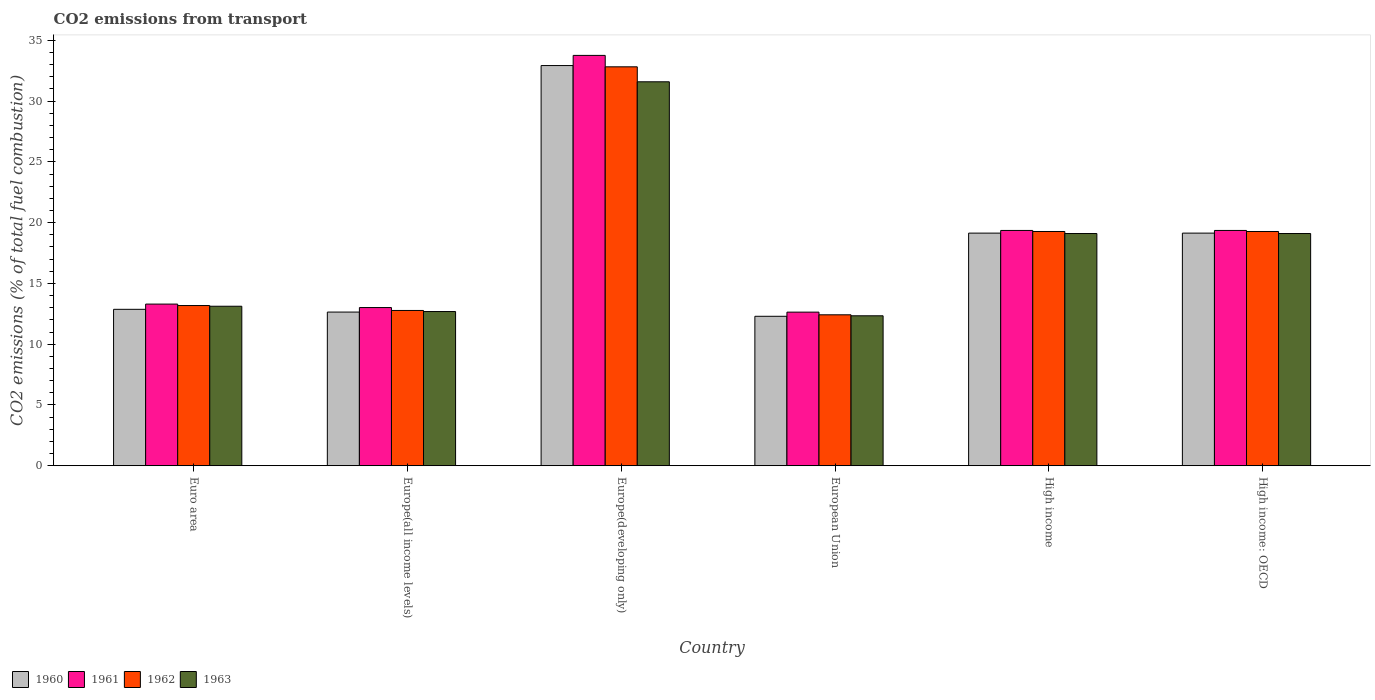How many bars are there on the 3rd tick from the left?
Offer a terse response. 4. What is the label of the 6th group of bars from the left?
Keep it short and to the point. High income: OECD. What is the total CO2 emitted in 1962 in Euro area?
Your response must be concise. 13.18. Across all countries, what is the maximum total CO2 emitted in 1961?
Provide a short and direct response. 33.76. Across all countries, what is the minimum total CO2 emitted in 1963?
Your response must be concise. 12.34. In which country was the total CO2 emitted in 1961 maximum?
Keep it short and to the point. Europe(developing only). In which country was the total CO2 emitted in 1962 minimum?
Offer a terse response. European Union. What is the total total CO2 emitted in 1962 in the graph?
Ensure brevity in your answer.  109.75. What is the difference between the total CO2 emitted in 1961 in Euro area and that in High income: OECD?
Your answer should be compact. -6.06. What is the difference between the total CO2 emitted in 1962 in Euro area and the total CO2 emitted in 1960 in Europe(developing only)?
Offer a very short reply. -19.75. What is the average total CO2 emitted in 1963 per country?
Your response must be concise. 17.99. What is the difference between the total CO2 emitted of/in 1963 and total CO2 emitted of/in 1962 in Euro area?
Offer a terse response. -0.06. In how many countries, is the total CO2 emitted in 1963 greater than 34?
Your answer should be compact. 0. What is the ratio of the total CO2 emitted in 1960 in Euro area to that in High income: OECD?
Your answer should be compact. 0.67. Is the total CO2 emitted in 1962 in Europe(all income levels) less than that in High income: OECD?
Keep it short and to the point. Yes. Is the difference between the total CO2 emitted in 1963 in Europe(developing only) and High income: OECD greater than the difference between the total CO2 emitted in 1962 in Europe(developing only) and High income: OECD?
Your answer should be very brief. No. What is the difference between the highest and the second highest total CO2 emitted in 1960?
Keep it short and to the point. 13.79. What is the difference between the highest and the lowest total CO2 emitted in 1960?
Your answer should be very brief. 20.63. Is the sum of the total CO2 emitted in 1962 in Euro area and High income: OECD greater than the maximum total CO2 emitted in 1961 across all countries?
Your answer should be compact. No. Is it the case that in every country, the sum of the total CO2 emitted in 1961 and total CO2 emitted in 1963 is greater than the sum of total CO2 emitted in 1960 and total CO2 emitted in 1962?
Offer a terse response. No. What does the 4th bar from the left in European Union represents?
Make the answer very short. 1963. What does the 3rd bar from the right in European Union represents?
Ensure brevity in your answer.  1961. Are all the bars in the graph horizontal?
Provide a succinct answer. No. Does the graph contain any zero values?
Offer a terse response. No. How many legend labels are there?
Make the answer very short. 4. What is the title of the graph?
Keep it short and to the point. CO2 emissions from transport. What is the label or title of the X-axis?
Your response must be concise. Country. What is the label or title of the Y-axis?
Offer a terse response. CO2 emissions (% of total fuel combustion). What is the CO2 emissions (% of total fuel combustion) of 1960 in Euro area?
Your response must be concise. 12.87. What is the CO2 emissions (% of total fuel combustion) in 1961 in Euro area?
Offer a terse response. 13.3. What is the CO2 emissions (% of total fuel combustion) of 1962 in Euro area?
Offer a very short reply. 13.18. What is the CO2 emissions (% of total fuel combustion) in 1963 in Euro area?
Offer a very short reply. 13.12. What is the CO2 emissions (% of total fuel combustion) in 1960 in Europe(all income levels)?
Make the answer very short. 12.64. What is the CO2 emissions (% of total fuel combustion) in 1961 in Europe(all income levels)?
Keep it short and to the point. 13.01. What is the CO2 emissions (% of total fuel combustion) of 1962 in Europe(all income levels)?
Keep it short and to the point. 12.78. What is the CO2 emissions (% of total fuel combustion) of 1963 in Europe(all income levels)?
Provide a short and direct response. 12.69. What is the CO2 emissions (% of total fuel combustion) in 1960 in Europe(developing only)?
Keep it short and to the point. 32.93. What is the CO2 emissions (% of total fuel combustion) of 1961 in Europe(developing only)?
Offer a very short reply. 33.76. What is the CO2 emissions (% of total fuel combustion) of 1962 in Europe(developing only)?
Give a very brief answer. 32.82. What is the CO2 emissions (% of total fuel combustion) in 1963 in Europe(developing only)?
Provide a succinct answer. 31.59. What is the CO2 emissions (% of total fuel combustion) in 1960 in European Union?
Offer a very short reply. 12.3. What is the CO2 emissions (% of total fuel combustion) in 1961 in European Union?
Your response must be concise. 12.64. What is the CO2 emissions (% of total fuel combustion) of 1962 in European Union?
Ensure brevity in your answer.  12.42. What is the CO2 emissions (% of total fuel combustion) in 1963 in European Union?
Offer a terse response. 12.34. What is the CO2 emissions (% of total fuel combustion) in 1960 in High income?
Your answer should be compact. 19.14. What is the CO2 emissions (% of total fuel combustion) in 1961 in High income?
Provide a short and direct response. 19.36. What is the CO2 emissions (% of total fuel combustion) in 1962 in High income?
Your answer should be very brief. 19.27. What is the CO2 emissions (% of total fuel combustion) in 1963 in High income?
Make the answer very short. 19.11. What is the CO2 emissions (% of total fuel combustion) of 1960 in High income: OECD?
Make the answer very short. 19.14. What is the CO2 emissions (% of total fuel combustion) in 1961 in High income: OECD?
Offer a very short reply. 19.36. What is the CO2 emissions (% of total fuel combustion) in 1962 in High income: OECD?
Offer a terse response. 19.27. What is the CO2 emissions (% of total fuel combustion) of 1963 in High income: OECD?
Offer a very short reply. 19.11. Across all countries, what is the maximum CO2 emissions (% of total fuel combustion) of 1960?
Make the answer very short. 32.93. Across all countries, what is the maximum CO2 emissions (% of total fuel combustion) of 1961?
Provide a succinct answer. 33.76. Across all countries, what is the maximum CO2 emissions (% of total fuel combustion) in 1962?
Give a very brief answer. 32.82. Across all countries, what is the maximum CO2 emissions (% of total fuel combustion) of 1963?
Offer a terse response. 31.59. Across all countries, what is the minimum CO2 emissions (% of total fuel combustion) in 1960?
Provide a short and direct response. 12.3. Across all countries, what is the minimum CO2 emissions (% of total fuel combustion) of 1961?
Keep it short and to the point. 12.64. Across all countries, what is the minimum CO2 emissions (% of total fuel combustion) of 1962?
Your answer should be compact. 12.42. Across all countries, what is the minimum CO2 emissions (% of total fuel combustion) in 1963?
Your answer should be compact. 12.34. What is the total CO2 emissions (% of total fuel combustion) of 1960 in the graph?
Give a very brief answer. 109.02. What is the total CO2 emissions (% of total fuel combustion) of 1961 in the graph?
Offer a very short reply. 111.44. What is the total CO2 emissions (% of total fuel combustion) of 1962 in the graph?
Provide a short and direct response. 109.75. What is the total CO2 emissions (% of total fuel combustion) in 1963 in the graph?
Make the answer very short. 107.96. What is the difference between the CO2 emissions (% of total fuel combustion) of 1960 in Euro area and that in Europe(all income levels)?
Make the answer very short. 0.23. What is the difference between the CO2 emissions (% of total fuel combustion) of 1961 in Euro area and that in Europe(all income levels)?
Provide a succinct answer. 0.29. What is the difference between the CO2 emissions (% of total fuel combustion) in 1962 in Euro area and that in Europe(all income levels)?
Your response must be concise. 0.41. What is the difference between the CO2 emissions (% of total fuel combustion) of 1963 in Euro area and that in Europe(all income levels)?
Offer a terse response. 0.44. What is the difference between the CO2 emissions (% of total fuel combustion) of 1960 in Euro area and that in Europe(developing only)?
Offer a very short reply. -20.06. What is the difference between the CO2 emissions (% of total fuel combustion) in 1961 in Euro area and that in Europe(developing only)?
Offer a terse response. -20.46. What is the difference between the CO2 emissions (% of total fuel combustion) in 1962 in Euro area and that in Europe(developing only)?
Your answer should be compact. -19.64. What is the difference between the CO2 emissions (% of total fuel combustion) in 1963 in Euro area and that in Europe(developing only)?
Give a very brief answer. -18.47. What is the difference between the CO2 emissions (% of total fuel combustion) of 1960 in Euro area and that in European Union?
Offer a very short reply. 0.57. What is the difference between the CO2 emissions (% of total fuel combustion) in 1961 in Euro area and that in European Union?
Provide a short and direct response. 0.66. What is the difference between the CO2 emissions (% of total fuel combustion) in 1962 in Euro area and that in European Union?
Give a very brief answer. 0.76. What is the difference between the CO2 emissions (% of total fuel combustion) in 1963 in Euro area and that in European Union?
Your answer should be compact. 0.79. What is the difference between the CO2 emissions (% of total fuel combustion) in 1960 in Euro area and that in High income?
Provide a short and direct response. -6.27. What is the difference between the CO2 emissions (% of total fuel combustion) in 1961 in Euro area and that in High income?
Keep it short and to the point. -6.06. What is the difference between the CO2 emissions (% of total fuel combustion) in 1962 in Euro area and that in High income?
Make the answer very short. -6.09. What is the difference between the CO2 emissions (% of total fuel combustion) in 1963 in Euro area and that in High income?
Make the answer very short. -5.98. What is the difference between the CO2 emissions (% of total fuel combustion) of 1960 in Euro area and that in High income: OECD?
Your answer should be compact. -6.27. What is the difference between the CO2 emissions (% of total fuel combustion) of 1961 in Euro area and that in High income: OECD?
Your answer should be very brief. -6.06. What is the difference between the CO2 emissions (% of total fuel combustion) in 1962 in Euro area and that in High income: OECD?
Offer a very short reply. -6.09. What is the difference between the CO2 emissions (% of total fuel combustion) of 1963 in Euro area and that in High income: OECD?
Offer a terse response. -5.98. What is the difference between the CO2 emissions (% of total fuel combustion) of 1960 in Europe(all income levels) and that in Europe(developing only)?
Provide a succinct answer. -20.28. What is the difference between the CO2 emissions (% of total fuel combustion) in 1961 in Europe(all income levels) and that in Europe(developing only)?
Your answer should be very brief. -20.75. What is the difference between the CO2 emissions (% of total fuel combustion) in 1962 in Europe(all income levels) and that in Europe(developing only)?
Your response must be concise. -20.05. What is the difference between the CO2 emissions (% of total fuel combustion) of 1963 in Europe(all income levels) and that in Europe(developing only)?
Keep it short and to the point. -18.9. What is the difference between the CO2 emissions (% of total fuel combustion) of 1960 in Europe(all income levels) and that in European Union?
Provide a short and direct response. 0.35. What is the difference between the CO2 emissions (% of total fuel combustion) of 1961 in Europe(all income levels) and that in European Union?
Keep it short and to the point. 0.38. What is the difference between the CO2 emissions (% of total fuel combustion) in 1962 in Europe(all income levels) and that in European Union?
Provide a succinct answer. 0.36. What is the difference between the CO2 emissions (% of total fuel combustion) in 1963 in Europe(all income levels) and that in European Union?
Your answer should be compact. 0.35. What is the difference between the CO2 emissions (% of total fuel combustion) of 1960 in Europe(all income levels) and that in High income?
Offer a very short reply. -6.5. What is the difference between the CO2 emissions (% of total fuel combustion) in 1961 in Europe(all income levels) and that in High income?
Provide a succinct answer. -6.35. What is the difference between the CO2 emissions (% of total fuel combustion) in 1962 in Europe(all income levels) and that in High income?
Ensure brevity in your answer.  -6.5. What is the difference between the CO2 emissions (% of total fuel combustion) in 1963 in Europe(all income levels) and that in High income?
Your response must be concise. -6.42. What is the difference between the CO2 emissions (% of total fuel combustion) of 1960 in Europe(all income levels) and that in High income: OECD?
Make the answer very short. -6.5. What is the difference between the CO2 emissions (% of total fuel combustion) of 1961 in Europe(all income levels) and that in High income: OECD?
Give a very brief answer. -6.35. What is the difference between the CO2 emissions (% of total fuel combustion) in 1962 in Europe(all income levels) and that in High income: OECD?
Offer a very short reply. -6.5. What is the difference between the CO2 emissions (% of total fuel combustion) of 1963 in Europe(all income levels) and that in High income: OECD?
Ensure brevity in your answer.  -6.42. What is the difference between the CO2 emissions (% of total fuel combustion) of 1960 in Europe(developing only) and that in European Union?
Keep it short and to the point. 20.63. What is the difference between the CO2 emissions (% of total fuel combustion) in 1961 in Europe(developing only) and that in European Union?
Provide a short and direct response. 21.13. What is the difference between the CO2 emissions (% of total fuel combustion) in 1962 in Europe(developing only) and that in European Union?
Give a very brief answer. 20.41. What is the difference between the CO2 emissions (% of total fuel combustion) in 1963 in Europe(developing only) and that in European Union?
Offer a very short reply. 19.25. What is the difference between the CO2 emissions (% of total fuel combustion) in 1960 in Europe(developing only) and that in High income?
Offer a terse response. 13.79. What is the difference between the CO2 emissions (% of total fuel combustion) of 1961 in Europe(developing only) and that in High income?
Keep it short and to the point. 14.4. What is the difference between the CO2 emissions (% of total fuel combustion) of 1962 in Europe(developing only) and that in High income?
Provide a succinct answer. 13.55. What is the difference between the CO2 emissions (% of total fuel combustion) of 1963 in Europe(developing only) and that in High income?
Offer a very short reply. 12.48. What is the difference between the CO2 emissions (% of total fuel combustion) in 1960 in Europe(developing only) and that in High income: OECD?
Your answer should be compact. 13.79. What is the difference between the CO2 emissions (% of total fuel combustion) in 1961 in Europe(developing only) and that in High income: OECD?
Keep it short and to the point. 14.4. What is the difference between the CO2 emissions (% of total fuel combustion) in 1962 in Europe(developing only) and that in High income: OECD?
Ensure brevity in your answer.  13.55. What is the difference between the CO2 emissions (% of total fuel combustion) in 1963 in Europe(developing only) and that in High income: OECD?
Keep it short and to the point. 12.48. What is the difference between the CO2 emissions (% of total fuel combustion) of 1960 in European Union and that in High income?
Ensure brevity in your answer.  -6.84. What is the difference between the CO2 emissions (% of total fuel combustion) of 1961 in European Union and that in High income?
Your answer should be compact. -6.72. What is the difference between the CO2 emissions (% of total fuel combustion) in 1962 in European Union and that in High income?
Keep it short and to the point. -6.86. What is the difference between the CO2 emissions (% of total fuel combustion) in 1963 in European Union and that in High income?
Make the answer very short. -6.77. What is the difference between the CO2 emissions (% of total fuel combustion) in 1960 in European Union and that in High income: OECD?
Give a very brief answer. -6.84. What is the difference between the CO2 emissions (% of total fuel combustion) in 1961 in European Union and that in High income: OECD?
Your response must be concise. -6.72. What is the difference between the CO2 emissions (% of total fuel combustion) of 1962 in European Union and that in High income: OECD?
Your answer should be compact. -6.86. What is the difference between the CO2 emissions (% of total fuel combustion) of 1963 in European Union and that in High income: OECD?
Give a very brief answer. -6.77. What is the difference between the CO2 emissions (% of total fuel combustion) of 1961 in High income and that in High income: OECD?
Your answer should be very brief. 0. What is the difference between the CO2 emissions (% of total fuel combustion) of 1960 in Euro area and the CO2 emissions (% of total fuel combustion) of 1961 in Europe(all income levels)?
Ensure brevity in your answer.  -0.14. What is the difference between the CO2 emissions (% of total fuel combustion) of 1960 in Euro area and the CO2 emissions (% of total fuel combustion) of 1962 in Europe(all income levels)?
Your answer should be compact. 0.09. What is the difference between the CO2 emissions (% of total fuel combustion) in 1960 in Euro area and the CO2 emissions (% of total fuel combustion) in 1963 in Europe(all income levels)?
Ensure brevity in your answer.  0.18. What is the difference between the CO2 emissions (% of total fuel combustion) of 1961 in Euro area and the CO2 emissions (% of total fuel combustion) of 1962 in Europe(all income levels)?
Provide a succinct answer. 0.53. What is the difference between the CO2 emissions (% of total fuel combustion) in 1961 in Euro area and the CO2 emissions (% of total fuel combustion) in 1963 in Europe(all income levels)?
Your answer should be very brief. 0.61. What is the difference between the CO2 emissions (% of total fuel combustion) of 1962 in Euro area and the CO2 emissions (% of total fuel combustion) of 1963 in Europe(all income levels)?
Your answer should be very brief. 0.49. What is the difference between the CO2 emissions (% of total fuel combustion) of 1960 in Euro area and the CO2 emissions (% of total fuel combustion) of 1961 in Europe(developing only)?
Give a very brief answer. -20.89. What is the difference between the CO2 emissions (% of total fuel combustion) in 1960 in Euro area and the CO2 emissions (% of total fuel combustion) in 1962 in Europe(developing only)?
Provide a short and direct response. -19.95. What is the difference between the CO2 emissions (% of total fuel combustion) of 1960 in Euro area and the CO2 emissions (% of total fuel combustion) of 1963 in Europe(developing only)?
Offer a terse response. -18.72. What is the difference between the CO2 emissions (% of total fuel combustion) in 1961 in Euro area and the CO2 emissions (% of total fuel combustion) in 1962 in Europe(developing only)?
Your response must be concise. -19.52. What is the difference between the CO2 emissions (% of total fuel combustion) of 1961 in Euro area and the CO2 emissions (% of total fuel combustion) of 1963 in Europe(developing only)?
Provide a short and direct response. -18.29. What is the difference between the CO2 emissions (% of total fuel combustion) of 1962 in Euro area and the CO2 emissions (% of total fuel combustion) of 1963 in Europe(developing only)?
Ensure brevity in your answer.  -18.41. What is the difference between the CO2 emissions (% of total fuel combustion) of 1960 in Euro area and the CO2 emissions (% of total fuel combustion) of 1961 in European Union?
Make the answer very short. 0.23. What is the difference between the CO2 emissions (% of total fuel combustion) of 1960 in Euro area and the CO2 emissions (% of total fuel combustion) of 1962 in European Union?
Give a very brief answer. 0.45. What is the difference between the CO2 emissions (% of total fuel combustion) in 1960 in Euro area and the CO2 emissions (% of total fuel combustion) in 1963 in European Union?
Offer a very short reply. 0.53. What is the difference between the CO2 emissions (% of total fuel combustion) in 1961 in Euro area and the CO2 emissions (% of total fuel combustion) in 1962 in European Union?
Keep it short and to the point. 0.88. What is the difference between the CO2 emissions (% of total fuel combustion) in 1961 in Euro area and the CO2 emissions (% of total fuel combustion) in 1963 in European Union?
Provide a succinct answer. 0.96. What is the difference between the CO2 emissions (% of total fuel combustion) of 1962 in Euro area and the CO2 emissions (% of total fuel combustion) of 1963 in European Union?
Offer a terse response. 0.84. What is the difference between the CO2 emissions (% of total fuel combustion) in 1960 in Euro area and the CO2 emissions (% of total fuel combustion) in 1961 in High income?
Your answer should be compact. -6.49. What is the difference between the CO2 emissions (% of total fuel combustion) in 1960 in Euro area and the CO2 emissions (% of total fuel combustion) in 1962 in High income?
Your answer should be compact. -6.4. What is the difference between the CO2 emissions (% of total fuel combustion) of 1960 in Euro area and the CO2 emissions (% of total fuel combustion) of 1963 in High income?
Provide a succinct answer. -6.24. What is the difference between the CO2 emissions (% of total fuel combustion) in 1961 in Euro area and the CO2 emissions (% of total fuel combustion) in 1962 in High income?
Offer a terse response. -5.97. What is the difference between the CO2 emissions (% of total fuel combustion) of 1961 in Euro area and the CO2 emissions (% of total fuel combustion) of 1963 in High income?
Provide a succinct answer. -5.81. What is the difference between the CO2 emissions (% of total fuel combustion) of 1962 in Euro area and the CO2 emissions (% of total fuel combustion) of 1963 in High income?
Offer a very short reply. -5.93. What is the difference between the CO2 emissions (% of total fuel combustion) in 1960 in Euro area and the CO2 emissions (% of total fuel combustion) in 1961 in High income: OECD?
Offer a terse response. -6.49. What is the difference between the CO2 emissions (% of total fuel combustion) in 1960 in Euro area and the CO2 emissions (% of total fuel combustion) in 1962 in High income: OECD?
Your answer should be very brief. -6.4. What is the difference between the CO2 emissions (% of total fuel combustion) of 1960 in Euro area and the CO2 emissions (% of total fuel combustion) of 1963 in High income: OECD?
Your answer should be very brief. -6.24. What is the difference between the CO2 emissions (% of total fuel combustion) in 1961 in Euro area and the CO2 emissions (% of total fuel combustion) in 1962 in High income: OECD?
Ensure brevity in your answer.  -5.97. What is the difference between the CO2 emissions (% of total fuel combustion) in 1961 in Euro area and the CO2 emissions (% of total fuel combustion) in 1963 in High income: OECD?
Ensure brevity in your answer.  -5.81. What is the difference between the CO2 emissions (% of total fuel combustion) in 1962 in Euro area and the CO2 emissions (% of total fuel combustion) in 1963 in High income: OECD?
Your response must be concise. -5.93. What is the difference between the CO2 emissions (% of total fuel combustion) in 1960 in Europe(all income levels) and the CO2 emissions (% of total fuel combustion) in 1961 in Europe(developing only)?
Give a very brief answer. -21.12. What is the difference between the CO2 emissions (% of total fuel combustion) of 1960 in Europe(all income levels) and the CO2 emissions (% of total fuel combustion) of 1962 in Europe(developing only)?
Your answer should be compact. -20.18. What is the difference between the CO2 emissions (% of total fuel combustion) in 1960 in Europe(all income levels) and the CO2 emissions (% of total fuel combustion) in 1963 in Europe(developing only)?
Your answer should be compact. -18.95. What is the difference between the CO2 emissions (% of total fuel combustion) of 1961 in Europe(all income levels) and the CO2 emissions (% of total fuel combustion) of 1962 in Europe(developing only)?
Offer a very short reply. -19.81. What is the difference between the CO2 emissions (% of total fuel combustion) of 1961 in Europe(all income levels) and the CO2 emissions (% of total fuel combustion) of 1963 in Europe(developing only)?
Make the answer very short. -18.58. What is the difference between the CO2 emissions (% of total fuel combustion) in 1962 in Europe(all income levels) and the CO2 emissions (% of total fuel combustion) in 1963 in Europe(developing only)?
Provide a short and direct response. -18.82. What is the difference between the CO2 emissions (% of total fuel combustion) in 1960 in Europe(all income levels) and the CO2 emissions (% of total fuel combustion) in 1961 in European Union?
Make the answer very short. 0.01. What is the difference between the CO2 emissions (% of total fuel combustion) in 1960 in Europe(all income levels) and the CO2 emissions (% of total fuel combustion) in 1962 in European Union?
Provide a short and direct response. 0.23. What is the difference between the CO2 emissions (% of total fuel combustion) in 1960 in Europe(all income levels) and the CO2 emissions (% of total fuel combustion) in 1963 in European Union?
Your answer should be very brief. 0.31. What is the difference between the CO2 emissions (% of total fuel combustion) of 1961 in Europe(all income levels) and the CO2 emissions (% of total fuel combustion) of 1962 in European Union?
Offer a very short reply. 0.6. What is the difference between the CO2 emissions (% of total fuel combustion) of 1961 in Europe(all income levels) and the CO2 emissions (% of total fuel combustion) of 1963 in European Union?
Give a very brief answer. 0.68. What is the difference between the CO2 emissions (% of total fuel combustion) in 1962 in Europe(all income levels) and the CO2 emissions (% of total fuel combustion) in 1963 in European Union?
Your response must be concise. 0.44. What is the difference between the CO2 emissions (% of total fuel combustion) in 1960 in Europe(all income levels) and the CO2 emissions (% of total fuel combustion) in 1961 in High income?
Make the answer very short. -6.72. What is the difference between the CO2 emissions (% of total fuel combustion) in 1960 in Europe(all income levels) and the CO2 emissions (% of total fuel combustion) in 1962 in High income?
Make the answer very short. -6.63. What is the difference between the CO2 emissions (% of total fuel combustion) of 1960 in Europe(all income levels) and the CO2 emissions (% of total fuel combustion) of 1963 in High income?
Make the answer very short. -6.46. What is the difference between the CO2 emissions (% of total fuel combustion) in 1961 in Europe(all income levels) and the CO2 emissions (% of total fuel combustion) in 1962 in High income?
Your response must be concise. -6.26. What is the difference between the CO2 emissions (% of total fuel combustion) in 1961 in Europe(all income levels) and the CO2 emissions (% of total fuel combustion) in 1963 in High income?
Make the answer very short. -6.09. What is the difference between the CO2 emissions (% of total fuel combustion) of 1962 in Europe(all income levels) and the CO2 emissions (% of total fuel combustion) of 1963 in High income?
Ensure brevity in your answer.  -6.33. What is the difference between the CO2 emissions (% of total fuel combustion) in 1960 in Europe(all income levels) and the CO2 emissions (% of total fuel combustion) in 1961 in High income: OECD?
Make the answer very short. -6.72. What is the difference between the CO2 emissions (% of total fuel combustion) in 1960 in Europe(all income levels) and the CO2 emissions (% of total fuel combustion) in 1962 in High income: OECD?
Your answer should be very brief. -6.63. What is the difference between the CO2 emissions (% of total fuel combustion) in 1960 in Europe(all income levels) and the CO2 emissions (% of total fuel combustion) in 1963 in High income: OECD?
Ensure brevity in your answer.  -6.46. What is the difference between the CO2 emissions (% of total fuel combustion) in 1961 in Europe(all income levels) and the CO2 emissions (% of total fuel combustion) in 1962 in High income: OECD?
Your answer should be compact. -6.26. What is the difference between the CO2 emissions (% of total fuel combustion) in 1961 in Europe(all income levels) and the CO2 emissions (% of total fuel combustion) in 1963 in High income: OECD?
Offer a very short reply. -6.09. What is the difference between the CO2 emissions (% of total fuel combustion) of 1962 in Europe(all income levels) and the CO2 emissions (% of total fuel combustion) of 1963 in High income: OECD?
Ensure brevity in your answer.  -6.33. What is the difference between the CO2 emissions (% of total fuel combustion) of 1960 in Europe(developing only) and the CO2 emissions (% of total fuel combustion) of 1961 in European Union?
Keep it short and to the point. 20.29. What is the difference between the CO2 emissions (% of total fuel combustion) of 1960 in Europe(developing only) and the CO2 emissions (% of total fuel combustion) of 1962 in European Union?
Give a very brief answer. 20.51. What is the difference between the CO2 emissions (% of total fuel combustion) in 1960 in Europe(developing only) and the CO2 emissions (% of total fuel combustion) in 1963 in European Union?
Ensure brevity in your answer.  20.59. What is the difference between the CO2 emissions (% of total fuel combustion) in 1961 in Europe(developing only) and the CO2 emissions (% of total fuel combustion) in 1962 in European Union?
Offer a very short reply. 21.35. What is the difference between the CO2 emissions (% of total fuel combustion) of 1961 in Europe(developing only) and the CO2 emissions (% of total fuel combustion) of 1963 in European Union?
Ensure brevity in your answer.  21.43. What is the difference between the CO2 emissions (% of total fuel combustion) in 1962 in Europe(developing only) and the CO2 emissions (% of total fuel combustion) in 1963 in European Union?
Offer a very short reply. 20.49. What is the difference between the CO2 emissions (% of total fuel combustion) of 1960 in Europe(developing only) and the CO2 emissions (% of total fuel combustion) of 1961 in High income?
Provide a short and direct response. 13.57. What is the difference between the CO2 emissions (% of total fuel combustion) in 1960 in Europe(developing only) and the CO2 emissions (% of total fuel combustion) in 1962 in High income?
Your answer should be compact. 13.65. What is the difference between the CO2 emissions (% of total fuel combustion) of 1960 in Europe(developing only) and the CO2 emissions (% of total fuel combustion) of 1963 in High income?
Ensure brevity in your answer.  13.82. What is the difference between the CO2 emissions (% of total fuel combustion) in 1961 in Europe(developing only) and the CO2 emissions (% of total fuel combustion) in 1962 in High income?
Make the answer very short. 14.49. What is the difference between the CO2 emissions (% of total fuel combustion) of 1961 in Europe(developing only) and the CO2 emissions (% of total fuel combustion) of 1963 in High income?
Your answer should be very brief. 14.66. What is the difference between the CO2 emissions (% of total fuel combustion) in 1962 in Europe(developing only) and the CO2 emissions (% of total fuel combustion) in 1963 in High income?
Your answer should be very brief. 13.72. What is the difference between the CO2 emissions (% of total fuel combustion) in 1960 in Europe(developing only) and the CO2 emissions (% of total fuel combustion) in 1961 in High income: OECD?
Your answer should be compact. 13.57. What is the difference between the CO2 emissions (% of total fuel combustion) in 1960 in Europe(developing only) and the CO2 emissions (% of total fuel combustion) in 1962 in High income: OECD?
Your response must be concise. 13.65. What is the difference between the CO2 emissions (% of total fuel combustion) of 1960 in Europe(developing only) and the CO2 emissions (% of total fuel combustion) of 1963 in High income: OECD?
Your answer should be very brief. 13.82. What is the difference between the CO2 emissions (% of total fuel combustion) of 1961 in Europe(developing only) and the CO2 emissions (% of total fuel combustion) of 1962 in High income: OECD?
Provide a short and direct response. 14.49. What is the difference between the CO2 emissions (% of total fuel combustion) of 1961 in Europe(developing only) and the CO2 emissions (% of total fuel combustion) of 1963 in High income: OECD?
Provide a short and direct response. 14.66. What is the difference between the CO2 emissions (% of total fuel combustion) of 1962 in Europe(developing only) and the CO2 emissions (% of total fuel combustion) of 1963 in High income: OECD?
Your response must be concise. 13.72. What is the difference between the CO2 emissions (% of total fuel combustion) in 1960 in European Union and the CO2 emissions (% of total fuel combustion) in 1961 in High income?
Offer a terse response. -7.06. What is the difference between the CO2 emissions (% of total fuel combustion) of 1960 in European Union and the CO2 emissions (% of total fuel combustion) of 1962 in High income?
Make the answer very short. -6.98. What is the difference between the CO2 emissions (% of total fuel combustion) in 1960 in European Union and the CO2 emissions (% of total fuel combustion) in 1963 in High income?
Your response must be concise. -6.81. What is the difference between the CO2 emissions (% of total fuel combustion) of 1961 in European Union and the CO2 emissions (% of total fuel combustion) of 1962 in High income?
Your answer should be very brief. -6.64. What is the difference between the CO2 emissions (% of total fuel combustion) in 1961 in European Union and the CO2 emissions (% of total fuel combustion) in 1963 in High income?
Provide a short and direct response. -6.47. What is the difference between the CO2 emissions (% of total fuel combustion) in 1962 in European Union and the CO2 emissions (% of total fuel combustion) in 1963 in High income?
Keep it short and to the point. -6.69. What is the difference between the CO2 emissions (% of total fuel combustion) of 1960 in European Union and the CO2 emissions (% of total fuel combustion) of 1961 in High income: OECD?
Keep it short and to the point. -7.06. What is the difference between the CO2 emissions (% of total fuel combustion) of 1960 in European Union and the CO2 emissions (% of total fuel combustion) of 1962 in High income: OECD?
Offer a terse response. -6.98. What is the difference between the CO2 emissions (% of total fuel combustion) of 1960 in European Union and the CO2 emissions (% of total fuel combustion) of 1963 in High income: OECD?
Make the answer very short. -6.81. What is the difference between the CO2 emissions (% of total fuel combustion) in 1961 in European Union and the CO2 emissions (% of total fuel combustion) in 1962 in High income: OECD?
Offer a very short reply. -6.64. What is the difference between the CO2 emissions (% of total fuel combustion) of 1961 in European Union and the CO2 emissions (% of total fuel combustion) of 1963 in High income: OECD?
Your answer should be very brief. -6.47. What is the difference between the CO2 emissions (% of total fuel combustion) of 1962 in European Union and the CO2 emissions (% of total fuel combustion) of 1963 in High income: OECD?
Keep it short and to the point. -6.69. What is the difference between the CO2 emissions (% of total fuel combustion) in 1960 in High income and the CO2 emissions (% of total fuel combustion) in 1961 in High income: OECD?
Make the answer very short. -0.22. What is the difference between the CO2 emissions (% of total fuel combustion) of 1960 in High income and the CO2 emissions (% of total fuel combustion) of 1962 in High income: OECD?
Your answer should be compact. -0.13. What is the difference between the CO2 emissions (% of total fuel combustion) of 1960 in High income and the CO2 emissions (% of total fuel combustion) of 1963 in High income: OECD?
Ensure brevity in your answer.  0.03. What is the difference between the CO2 emissions (% of total fuel combustion) of 1961 in High income and the CO2 emissions (% of total fuel combustion) of 1962 in High income: OECD?
Ensure brevity in your answer.  0.09. What is the difference between the CO2 emissions (% of total fuel combustion) in 1961 in High income and the CO2 emissions (% of total fuel combustion) in 1963 in High income: OECD?
Your answer should be compact. 0.25. What is the difference between the CO2 emissions (% of total fuel combustion) in 1962 in High income and the CO2 emissions (% of total fuel combustion) in 1963 in High income: OECD?
Ensure brevity in your answer.  0.17. What is the average CO2 emissions (% of total fuel combustion) in 1960 per country?
Your answer should be compact. 18.17. What is the average CO2 emissions (% of total fuel combustion) of 1961 per country?
Ensure brevity in your answer.  18.57. What is the average CO2 emissions (% of total fuel combustion) in 1962 per country?
Provide a succinct answer. 18.29. What is the average CO2 emissions (% of total fuel combustion) of 1963 per country?
Your response must be concise. 17.99. What is the difference between the CO2 emissions (% of total fuel combustion) in 1960 and CO2 emissions (% of total fuel combustion) in 1961 in Euro area?
Provide a short and direct response. -0.43. What is the difference between the CO2 emissions (% of total fuel combustion) of 1960 and CO2 emissions (% of total fuel combustion) of 1962 in Euro area?
Your response must be concise. -0.31. What is the difference between the CO2 emissions (% of total fuel combustion) of 1960 and CO2 emissions (% of total fuel combustion) of 1963 in Euro area?
Offer a very short reply. -0.25. What is the difference between the CO2 emissions (% of total fuel combustion) in 1961 and CO2 emissions (% of total fuel combustion) in 1962 in Euro area?
Ensure brevity in your answer.  0.12. What is the difference between the CO2 emissions (% of total fuel combustion) in 1961 and CO2 emissions (% of total fuel combustion) in 1963 in Euro area?
Provide a short and direct response. 0.18. What is the difference between the CO2 emissions (% of total fuel combustion) in 1962 and CO2 emissions (% of total fuel combustion) in 1963 in Euro area?
Ensure brevity in your answer.  0.06. What is the difference between the CO2 emissions (% of total fuel combustion) of 1960 and CO2 emissions (% of total fuel combustion) of 1961 in Europe(all income levels)?
Your response must be concise. -0.37. What is the difference between the CO2 emissions (% of total fuel combustion) in 1960 and CO2 emissions (% of total fuel combustion) in 1962 in Europe(all income levels)?
Offer a very short reply. -0.13. What is the difference between the CO2 emissions (% of total fuel combustion) of 1960 and CO2 emissions (% of total fuel combustion) of 1963 in Europe(all income levels)?
Make the answer very short. -0.04. What is the difference between the CO2 emissions (% of total fuel combustion) of 1961 and CO2 emissions (% of total fuel combustion) of 1962 in Europe(all income levels)?
Offer a terse response. 0.24. What is the difference between the CO2 emissions (% of total fuel combustion) of 1961 and CO2 emissions (% of total fuel combustion) of 1963 in Europe(all income levels)?
Give a very brief answer. 0.33. What is the difference between the CO2 emissions (% of total fuel combustion) in 1962 and CO2 emissions (% of total fuel combustion) in 1963 in Europe(all income levels)?
Provide a succinct answer. 0.09. What is the difference between the CO2 emissions (% of total fuel combustion) of 1960 and CO2 emissions (% of total fuel combustion) of 1961 in Europe(developing only)?
Your response must be concise. -0.84. What is the difference between the CO2 emissions (% of total fuel combustion) in 1960 and CO2 emissions (% of total fuel combustion) in 1962 in Europe(developing only)?
Your response must be concise. 0.1. What is the difference between the CO2 emissions (% of total fuel combustion) in 1960 and CO2 emissions (% of total fuel combustion) in 1963 in Europe(developing only)?
Provide a short and direct response. 1.34. What is the difference between the CO2 emissions (% of total fuel combustion) in 1961 and CO2 emissions (% of total fuel combustion) in 1962 in Europe(developing only)?
Your answer should be very brief. 0.94. What is the difference between the CO2 emissions (% of total fuel combustion) in 1961 and CO2 emissions (% of total fuel combustion) in 1963 in Europe(developing only)?
Your answer should be compact. 2.17. What is the difference between the CO2 emissions (% of total fuel combustion) of 1962 and CO2 emissions (% of total fuel combustion) of 1963 in Europe(developing only)?
Provide a succinct answer. 1.23. What is the difference between the CO2 emissions (% of total fuel combustion) of 1960 and CO2 emissions (% of total fuel combustion) of 1961 in European Union?
Your response must be concise. -0.34. What is the difference between the CO2 emissions (% of total fuel combustion) of 1960 and CO2 emissions (% of total fuel combustion) of 1962 in European Union?
Offer a terse response. -0.12. What is the difference between the CO2 emissions (% of total fuel combustion) of 1960 and CO2 emissions (% of total fuel combustion) of 1963 in European Union?
Offer a terse response. -0.04. What is the difference between the CO2 emissions (% of total fuel combustion) in 1961 and CO2 emissions (% of total fuel combustion) in 1962 in European Union?
Offer a very short reply. 0.22. What is the difference between the CO2 emissions (% of total fuel combustion) in 1961 and CO2 emissions (% of total fuel combustion) in 1963 in European Union?
Your response must be concise. 0.3. What is the difference between the CO2 emissions (% of total fuel combustion) of 1962 and CO2 emissions (% of total fuel combustion) of 1963 in European Union?
Keep it short and to the point. 0.08. What is the difference between the CO2 emissions (% of total fuel combustion) in 1960 and CO2 emissions (% of total fuel combustion) in 1961 in High income?
Your answer should be compact. -0.22. What is the difference between the CO2 emissions (% of total fuel combustion) of 1960 and CO2 emissions (% of total fuel combustion) of 1962 in High income?
Give a very brief answer. -0.13. What is the difference between the CO2 emissions (% of total fuel combustion) of 1960 and CO2 emissions (% of total fuel combustion) of 1963 in High income?
Ensure brevity in your answer.  0.03. What is the difference between the CO2 emissions (% of total fuel combustion) in 1961 and CO2 emissions (% of total fuel combustion) in 1962 in High income?
Provide a succinct answer. 0.09. What is the difference between the CO2 emissions (% of total fuel combustion) in 1961 and CO2 emissions (% of total fuel combustion) in 1963 in High income?
Keep it short and to the point. 0.25. What is the difference between the CO2 emissions (% of total fuel combustion) in 1962 and CO2 emissions (% of total fuel combustion) in 1963 in High income?
Make the answer very short. 0.17. What is the difference between the CO2 emissions (% of total fuel combustion) of 1960 and CO2 emissions (% of total fuel combustion) of 1961 in High income: OECD?
Give a very brief answer. -0.22. What is the difference between the CO2 emissions (% of total fuel combustion) in 1960 and CO2 emissions (% of total fuel combustion) in 1962 in High income: OECD?
Provide a succinct answer. -0.13. What is the difference between the CO2 emissions (% of total fuel combustion) of 1960 and CO2 emissions (% of total fuel combustion) of 1963 in High income: OECD?
Provide a succinct answer. 0.03. What is the difference between the CO2 emissions (% of total fuel combustion) of 1961 and CO2 emissions (% of total fuel combustion) of 1962 in High income: OECD?
Offer a terse response. 0.09. What is the difference between the CO2 emissions (% of total fuel combustion) of 1961 and CO2 emissions (% of total fuel combustion) of 1963 in High income: OECD?
Give a very brief answer. 0.25. What is the difference between the CO2 emissions (% of total fuel combustion) in 1962 and CO2 emissions (% of total fuel combustion) in 1963 in High income: OECD?
Provide a succinct answer. 0.17. What is the ratio of the CO2 emissions (% of total fuel combustion) of 1960 in Euro area to that in Europe(all income levels)?
Make the answer very short. 1.02. What is the ratio of the CO2 emissions (% of total fuel combustion) of 1961 in Euro area to that in Europe(all income levels)?
Give a very brief answer. 1.02. What is the ratio of the CO2 emissions (% of total fuel combustion) in 1962 in Euro area to that in Europe(all income levels)?
Your answer should be very brief. 1.03. What is the ratio of the CO2 emissions (% of total fuel combustion) in 1963 in Euro area to that in Europe(all income levels)?
Offer a very short reply. 1.03. What is the ratio of the CO2 emissions (% of total fuel combustion) in 1960 in Euro area to that in Europe(developing only)?
Offer a terse response. 0.39. What is the ratio of the CO2 emissions (% of total fuel combustion) in 1961 in Euro area to that in Europe(developing only)?
Your answer should be very brief. 0.39. What is the ratio of the CO2 emissions (% of total fuel combustion) in 1962 in Euro area to that in Europe(developing only)?
Make the answer very short. 0.4. What is the ratio of the CO2 emissions (% of total fuel combustion) of 1963 in Euro area to that in Europe(developing only)?
Provide a succinct answer. 0.42. What is the ratio of the CO2 emissions (% of total fuel combustion) in 1960 in Euro area to that in European Union?
Your response must be concise. 1.05. What is the ratio of the CO2 emissions (% of total fuel combustion) in 1961 in Euro area to that in European Union?
Your answer should be compact. 1.05. What is the ratio of the CO2 emissions (% of total fuel combustion) in 1962 in Euro area to that in European Union?
Provide a short and direct response. 1.06. What is the ratio of the CO2 emissions (% of total fuel combustion) of 1963 in Euro area to that in European Union?
Keep it short and to the point. 1.06. What is the ratio of the CO2 emissions (% of total fuel combustion) of 1960 in Euro area to that in High income?
Give a very brief answer. 0.67. What is the ratio of the CO2 emissions (% of total fuel combustion) of 1961 in Euro area to that in High income?
Give a very brief answer. 0.69. What is the ratio of the CO2 emissions (% of total fuel combustion) in 1962 in Euro area to that in High income?
Ensure brevity in your answer.  0.68. What is the ratio of the CO2 emissions (% of total fuel combustion) of 1963 in Euro area to that in High income?
Offer a very short reply. 0.69. What is the ratio of the CO2 emissions (% of total fuel combustion) in 1960 in Euro area to that in High income: OECD?
Ensure brevity in your answer.  0.67. What is the ratio of the CO2 emissions (% of total fuel combustion) of 1961 in Euro area to that in High income: OECD?
Your answer should be compact. 0.69. What is the ratio of the CO2 emissions (% of total fuel combustion) in 1962 in Euro area to that in High income: OECD?
Provide a succinct answer. 0.68. What is the ratio of the CO2 emissions (% of total fuel combustion) of 1963 in Euro area to that in High income: OECD?
Offer a very short reply. 0.69. What is the ratio of the CO2 emissions (% of total fuel combustion) in 1960 in Europe(all income levels) to that in Europe(developing only)?
Your response must be concise. 0.38. What is the ratio of the CO2 emissions (% of total fuel combustion) of 1961 in Europe(all income levels) to that in Europe(developing only)?
Give a very brief answer. 0.39. What is the ratio of the CO2 emissions (% of total fuel combustion) of 1962 in Europe(all income levels) to that in Europe(developing only)?
Provide a succinct answer. 0.39. What is the ratio of the CO2 emissions (% of total fuel combustion) in 1963 in Europe(all income levels) to that in Europe(developing only)?
Provide a succinct answer. 0.4. What is the ratio of the CO2 emissions (% of total fuel combustion) in 1960 in Europe(all income levels) to that in European Union?
Your answer should be compact. 1.03. What is the ratio of the CO2 emissions (% of total fuel combustion) of 1961 in Europe(all income levels) to that in European Union?
Make the answer very short. 1.03. What is the ratio of the CO2 emissions (% of total fuel combustion) of 1962 in Europe(all income levels) to that in European Union?
Your answer should be very brief. 1.03. What is the ratio of the CO2 emissions (% of total fuel combustion) of 1963 in Europe(all income levels) to that in European Union?
Ensure brevity in your answer.  1.03. What is the ratio of the CO2 emissions (% of total fuel combustion) of 1960 in Europe(all income levels) to that in High income?
Give a very brief answer. 0.66. What is the ratio of the CO2 emissions (% of total fuel combustion) in 1961 in Europe(all income levels) to that in High income?
Provide a short and direct response. 0.67. What is the ratio of the CO2 emissions (% of total fuel combustion) of 1962 in Europe(all income levels) to that in High income?
Offer a very short reply. 0.66. What is the ratio of the CO2 emissions (% of total fuel combustion) in 1963 in Europe(all income levels) to that in High income?
Offer a terse response. 0.66. What is the ratio of the CO2 emissions (% of total fuel combustion) in 1960 in Europe(all income levels) to that in High income: OECD?
Give a very brief answer. 0.66. What is the ratio of the CO2 emissions (% of total fuel combustion) in 1961 in Europe(all income levels) to that in High income: OECD?
Give a very brief answer. 0.67. What is the ratio of the CO2 emissions (% of total fuel combustion) of 1962 in Europe(all income levels) to that in High income: OECD?
Keep it short and to the point. 0.66. What is the ratio of the CO2 emissions (% of total fuel combustion) in 1963 in Europe(all income levels) to that in High income: OECD?
Your response must be concise. 0.66. What is the ratio of the CO2 emissions (% of total fuel combustion) in 1960 in Europe(developing only) to that in European Union?
Keep it short and to the point. 2.68. What is the ratio of the CO2 emissions (% of total fuel combustion) of 1961 in Europe(developing only) to that in European Union?
Offer a terse response. 2.67. What is the ratio of the CO2 emissions (% of total fuel combustion) of 1962 in Europe(developing only) to that in European Union?
Provide a short and direct response. 2.64. What is the ratio of the CO2 emissions (% of total fuel combustion) of 1963 in Europe(developing only) to that in European Union?
Give a very brief answer. 2.56. What is the ratio of the CO2 emissions (% of total fuel combustion) of 1960 in Europe(developing only) to that in High income?
Make the answer very short. 1.72. What is the ratio of the CO2 emissions (% of total fuel combustion) of 1961 in Europe(developing only) to that in High income?
Provide a succinct answer. 1.74. What is the ratio of the CO2 emissions (% of total fuel combustion) of 1962 in Europe(developing only) to that in High income?
Make the answer very short. 1.7. What is the ratio of the CO2 emissions (% of total fuel combustion) in 1963 in Europe(developing only) to that in High income?
Offer a terse response. 1.65. What is the ratio of the CO2 emissions (% of total fuel combustion) of 1960 in Europe(developing only) to that in High income: OECD?
Ensure brevity in your answer.  1.72. What is the ratio of the CO2 emissions (% of total fuel combustion) of 1961 in Europe(developing only) to that in High income: OECD?
Keep it short and to the point. 1.74. What is the ratio of the CO2 emissions (% of total fuel combustion) in 1962 in Europe(developing only) to that in High income: OECD?
Your answer should be compact. 1.7. What is the ratio of the CO2 emissions (% of total fuel combustion) in 1963 in Europe(developing only) to that in High income: OECD?
Ensure brevity in your answer.  1.65. What is the ratio of the CO2 emissions (% of total fuel combustion) of 1960 in European Union to that in High income?
Your answer should be very brief. 0.64. What is the ratio of the CO2 emissions (% of total fuel combustion) in 1961 in European Union to that in High income?
Your answer should be very brief. 0.65. What is the ratio of the CO2 emissions (% of total fuel combustion) of 1962 in European Union to that in High income?
Your answer should be very brief. 0.64. What is the ratio of the CO2 emissions (% of total fuel combustion) of 1963 in European Union to that in High income?
Keep it short and to the point. 0.65. What is the ratio of the CO2 emissions (% of total fuel combustion) of 1960 in European Union to that in High income: OECD?
Your answer should be very brief. 0.64. What is the ratio of the CO2 emissions (% of total fuel combustion) in 1961 in European Union to that in High income: OECD?
Give a very brief answer. 0.65. What is the ratio of the CO2 emissions (% of total fuel combustion) of 1962 in European Union to that in High income: OECD?
Give a very brief answer. 0.64. What is the ratio of the CO2 emissions (% of total fuel combustion) of 1963 in European Union to that in High income: OECD?
Offer a very short reply. 0.65. What is the ratio of the CO2 emissions (% of total fuel combustion) of 1960 in High income to that in High income: OECD?
Ensure brevity in your answer.  1. What is the ratio of the CO2 emissions (% of total fuel combustion) of 1961 in High income to that in High income: OECD?
Keep it short and to the point. 1. What is the ratio of the CO2 emissions (% of total fuel combustion) in 1962 in High income to that in High income: OECD?
Ensure brevity in your answer.  1. What is the ratio of the CO2 emissions (% of total fuel combustion) of 1963 in High income to that in High income: OECD?
Your answer should be very brief. 1. What is the difference between the highest and the second highest CO2 emissions (% of total fuel combustion) of 1960?
Provide a short and direct response. 13.79. What is the difference between the highest and the second highest CO2 emissions (% of total fuel combustion) in 1961?
Give a very brief answer. 14.4. What is the difference between the highest and the second highest CO2 emissions (% of total fuel combustion) in 1962?
Make the answer very short. 13.55. What is the difference between the highest and the second highest CO2 emissions (% of total fuel combustion) in 1963?
Give a very brief answer. 12.48. What is the difference between the highest and the lowest CO2 emissions (% of total fuel combustion) of 1960?
Offer a terse response. 20.63. What is the difference between the highest and the lowest CO2 emissions (% of total fuel combustion) of 1961?
Give a very brief answer. 21.13. What is the difference between the highest and the lowest CO2 emissions (% of total fuel combustion) of 1962?
Your answer should be compact. 20.41. What is the difference between the highest and the lowest CO2 emissions (% of total fuel combustion) in 1963?
Provide a short and direct response. 19.25. 